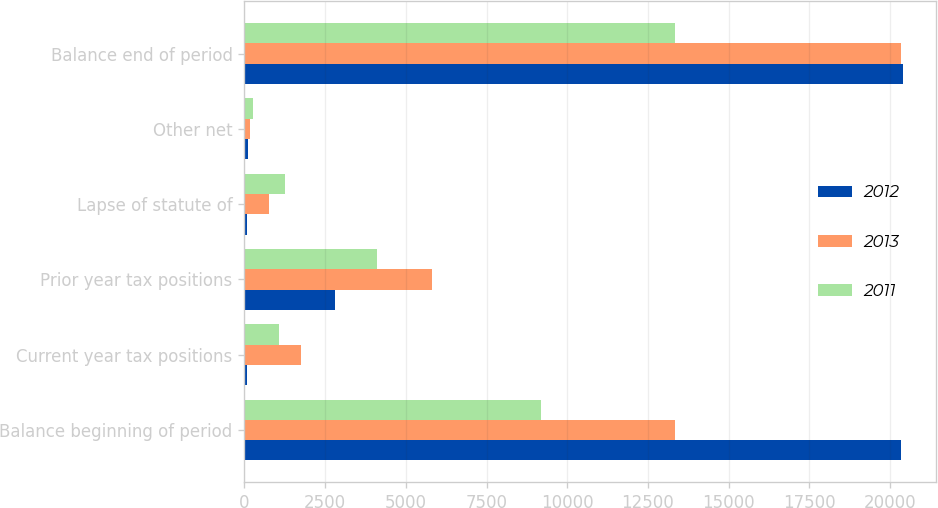<chart> <loc_0><loc_0><loc_500><loc_500><stacked_bar_chart><ecel><fcel>Balance beginning of period<fcel>Current year tax positions<fcel>Prior year tax positions<fcel>Lapse of statute of<fcel>Other net<fcel>Balance end of period<nl><fcel>2012<fcel>20328<fcel>73<fcel>2812<fcel>81<fcel>127<fcel>20400<nl><fcel>2013<fcel>13352<fcel>1741<fcel>5805<fcel>750<fcel>180<fcel>20328<nl><fcel>2011<fcel>9195<fcel>1077<fcel>4097<fcel>1273<fcel>256<fcel>13352<nl></chart> 